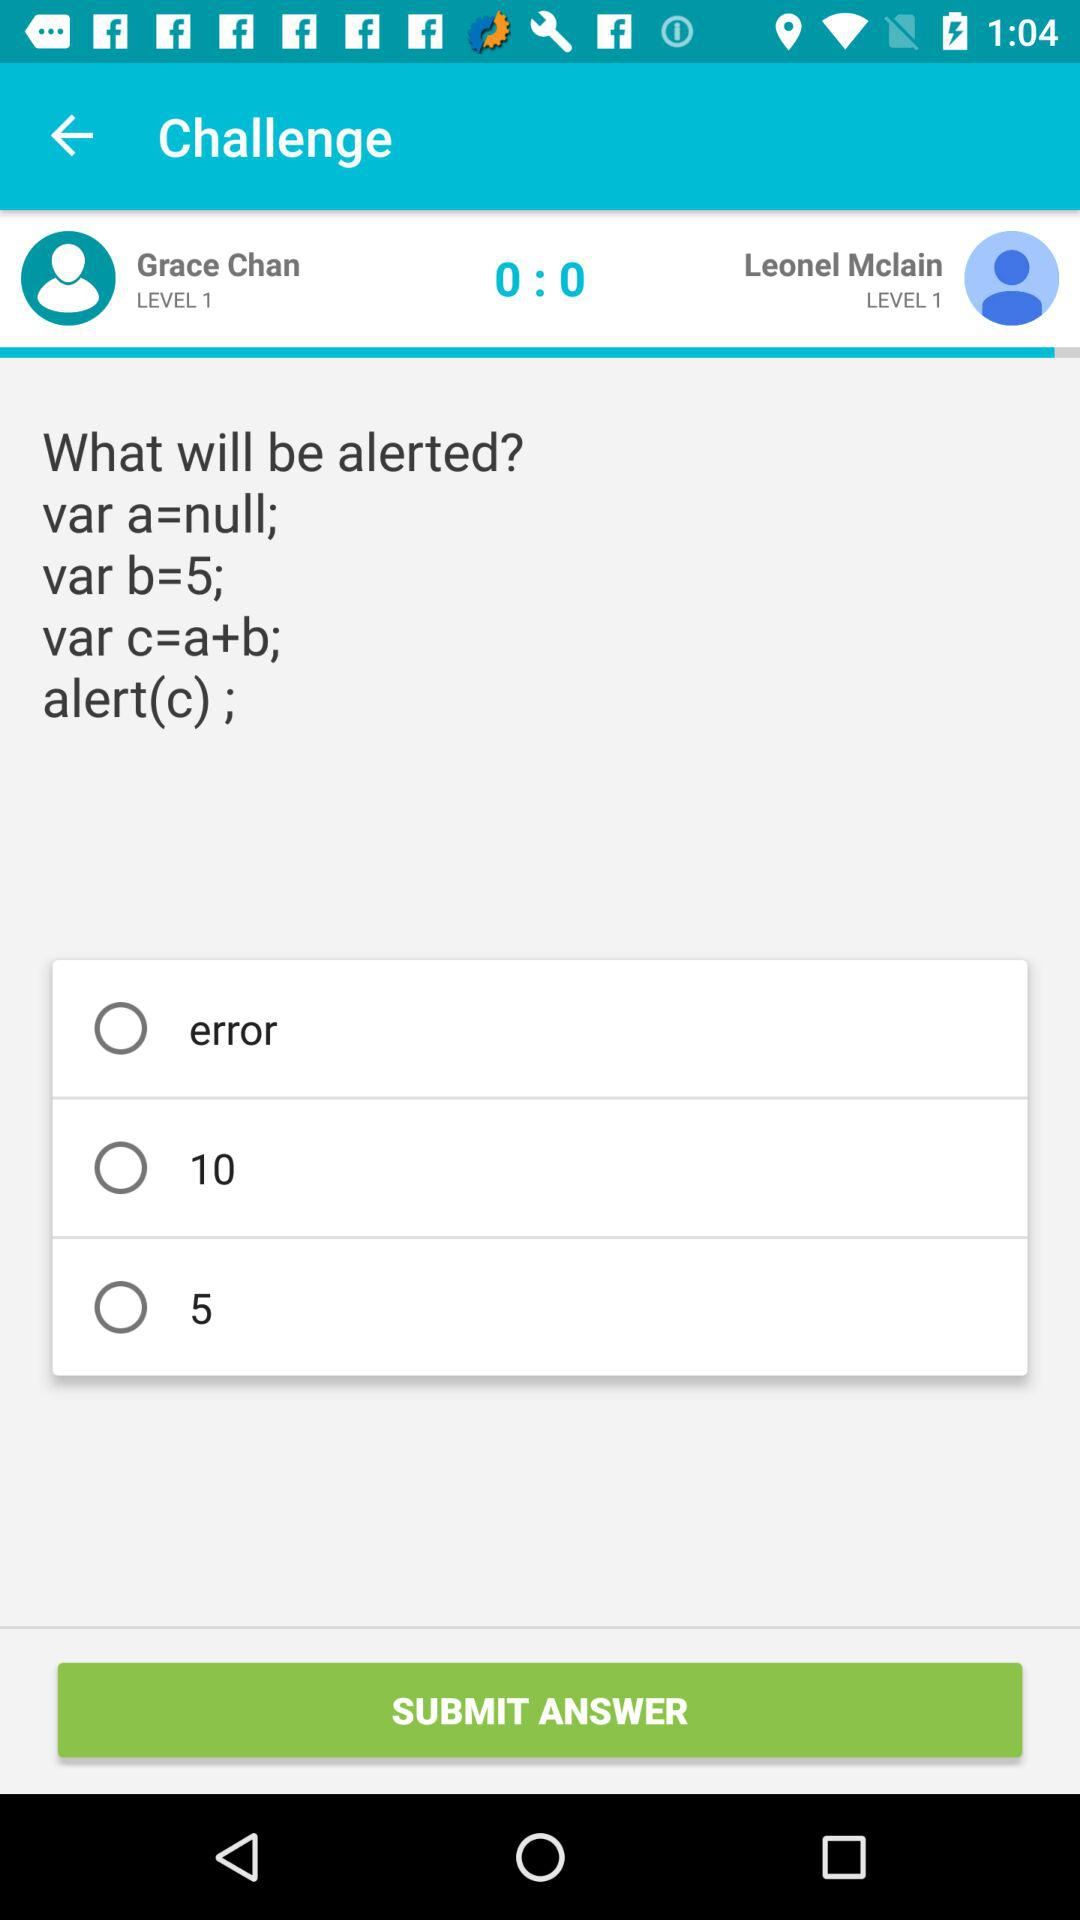What are the given names in the challenge? There are two given names: Grace Chan and Leonel Mclain. 